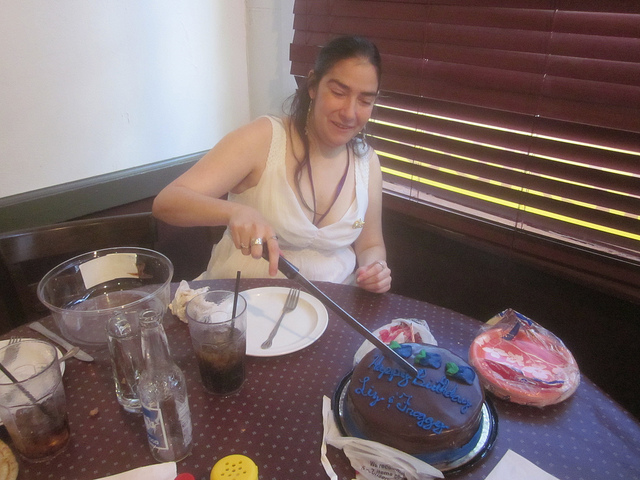Identify the text displayed in this image. Birthday 